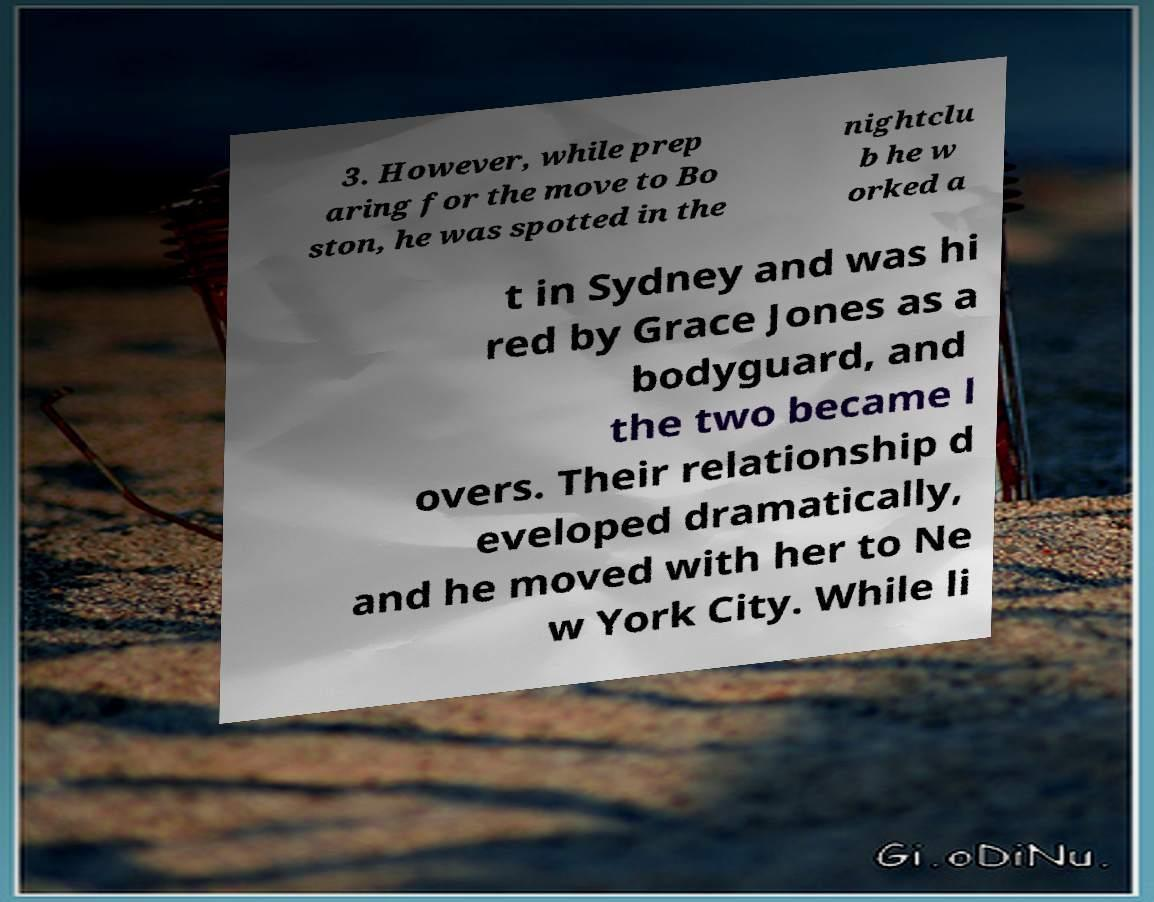Could you assist in decoding the text presented in this image and type it out clearly? 3. However, while prep aring for the move to Bo ston, he was spotted in the nightclu b he w orked a t in Sydney and was hi red by Grace Jones as a bodyguard, and the two became l overs. Their relationship d eveloped dramatically, and he moved with her to Ne w York City. While li 